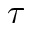<formula> <loc_0><loc_0><loc_500><loc_500>\tau</formula> 